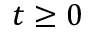<formula> <loc_0><loc_0><loc_500><loc_500>t \geq 0</formula> 